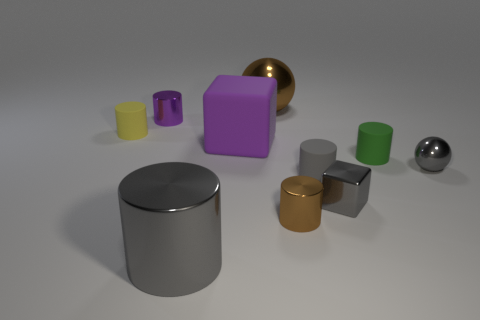Subtract all tiny gray matte cylinders. How many cylinders are left? 5 Subtract all blocks. How many objects are left? 8 Subtract 1 spheres. How many spheres are left? 1 Subtract all cyan balls. Subtract all gray cylinders. How many balls are left? 2 Subtract all purple cylinders. How many gray cubes are left? 1 Subtract all large blue matte cylinders. Subtract all tiny things. How many objects are left? 3 Add 4 brown metallic objects. How many brown metallic objects are left? 6 Add 2 shiny spheres. How many shiny spheres exist? 4 Subtract all brown balls. How many balls are left? 1 Subtract 0 cyan cubes. How many objects are left? 10 